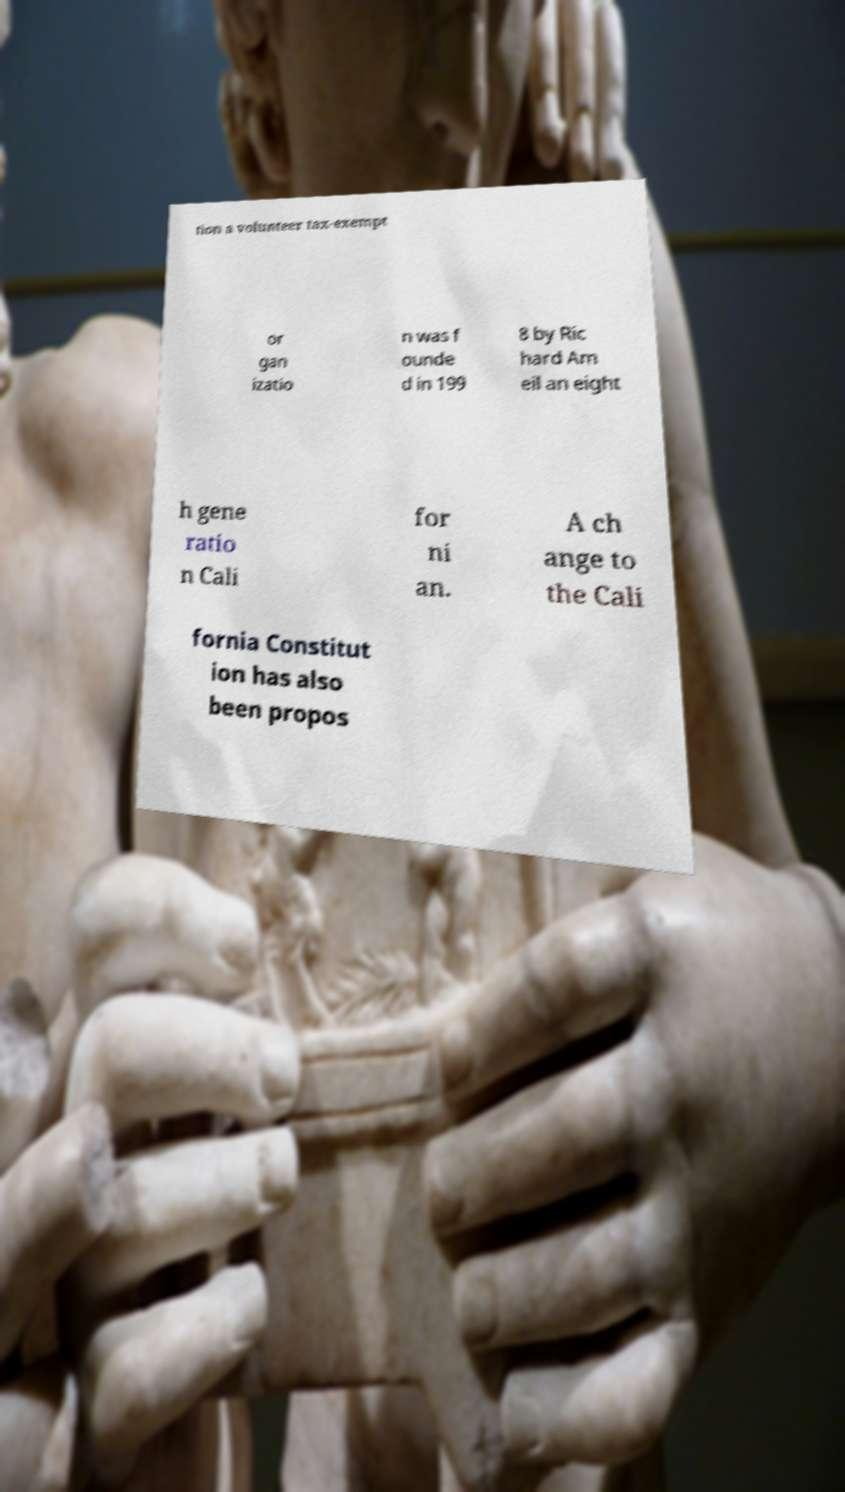I need the written content from this picture converted into text. Can you do that? tion a volunteer tax-exempt or gan izatio n was f ounde d in 199 8 by Ric hard Am eil an eight h gene ratio n Cali for ni an. A ch ange to the Cali fornia Constitut ion has also been propos 